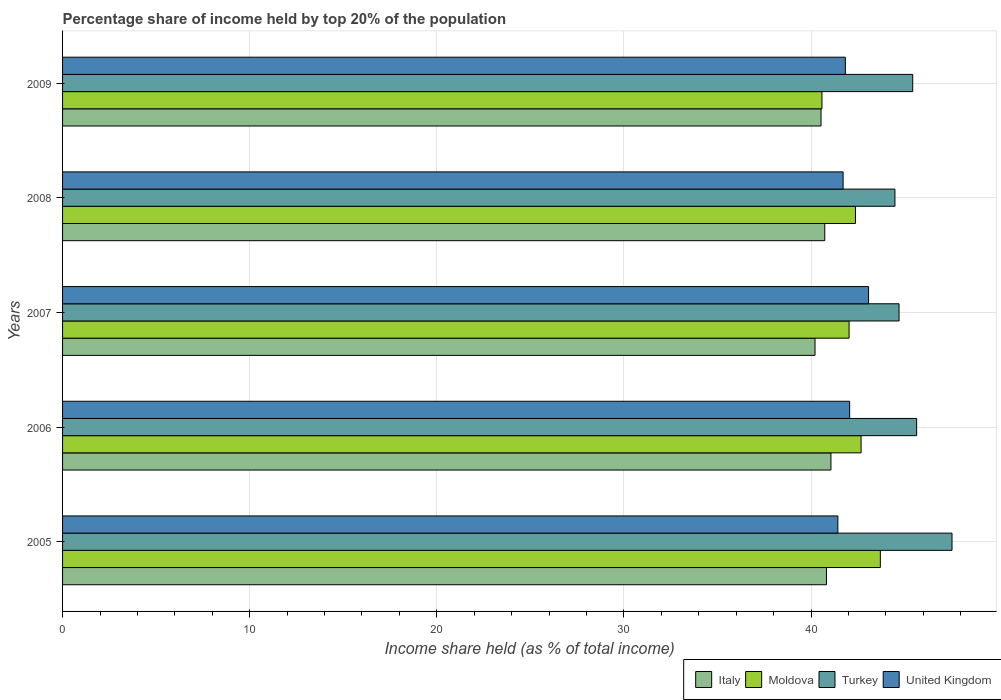How many different coloured bars are there?
Keep it short and to the point. 4. Are the number of bars per tick equal to the number of legend labels?
Your answer should be very brief. Yes. How many bars are there on the 1st tick from the top?
Ensure brevity in your answer.  4. What is the percentage share of income held by top 20% of the population in Turkey in 2005?
Offer a terse response. 47.53. Across all years, what is the maximum percentage share of income held by top 20% of the population in United Kingdom?
Offer a terse response. 43.07. Across all years, what is the minimum percentage share of income held by top 20% of the population in United Kingdom?
Offer a terse response. 41.43. In which year was the percentage share of income held by top 20% of the population in United Kingdom maximum?
Keep it short and to the point. 2007. What is the total percentage share of income held by top 20% of the population in Turkey in the graph?
Make the answer very short. 227.78. What is the difference between the percentage share of income held by top 20% of the population in Moldova in 2007 and that in 2008?
Ensure brevity in your answer.  -0.34. What is the difference between the percentage share of income held by top 20% of the population in United Kingdom in 2006 and the percentage share of income held by top 20% of the population in Turkey in 2009?
Offer a very short reply. -3.37. What is the average percentage share of income held by top 20% of the population in Turkey per year?
Keep it short and to the point. 45.56. In the year 2006, what is the difference between the percentage share of income held by top 20% of the population in Italy and percentage share of income held by top 20% of the population in Turkey?
Ensure brevity in your answer.  -4.58. In how many years, is the percentage share of income held by top 20% of the population in Turkey greater than 44 %?
Offer a terse response. 5. What is the ratio of the percentage share of income held by top 20% of the population in Moldova in 2007 to that in 2008?
Keep it short and to the point. 0.99. Is the percentage share of income held by top 20% of the population in Turkey in 2007 less than that in 2009?
Provide a succinct answer. Yes. What is the difference between the highest and the second highest percentage share of income held by top 20% of the population in Moldova?
Your answer should be very brief. 1.03. What is the difference between the highest and the lowest percentage share of income held by top 20% of the population in United Kingdom?
Your answer should be very brief. 1.64. Is the sum of the percentage share of income held by top 20% of the population in Italy in 2005 and 2008 greater than the maximum percentage share of income held by top 20% of the population in United Kingdom across all years?
Offer a very short reply. Yes. Is it the case that in every year, the sum of the percentage share of income held by top 20% of the population in Moldova and percentage share of income held by top 20% of the population in Turkey is greater than the sum of percentage share of income held by top 20% of the population in United Kingdom and percentage share of income held by top 20% of the population in Italy?
Keep it short and to the point. No. How many bars are there?
Provide a succinct answer. 20. How many years are there in the graph?
Provide a succinct answer. 5. Are the values on the major ticks of X-axis written in scientific E-notation?
Provide a succinct answer. No. Does the graph contain grids?
Offer a terse response. Yes. Where does the legend appear in the graph?
Your answer should be very brief. Bottom right. How many legend labels are there?
Ensure brevity in your answer.  4. What is the title of the graph?
Keep it short and to the point. Percentage share of income held by top 20% of the population. What is the label or title of the X-axis?
Your answer should be very brief. Income share held (as % of total income). What is the Income share held (as % of total income) in Italy in 2005?
Offer a terse response. 40.82. What is the Income share held (as % of total income) in Moldova in 2005?
Give a very brief answer. 43.7. What is the Income share held (as % of total income) in Turkey in 2005?
Offer a very short reply. 47.53. What is the Income share held (as % of total income) in United Kingdom in 2005?
Give a very brief answer. 41.43. What is the Income share held (as % of total income) in Italy in 2006?
Offer a terse response. 41.06. What is the Income share held (as % of total income) of Moldova in 2006?
Your answer should be compact. 42.67. What is the Income share held (as % of total income) in Turkey in 2006?
Your answer should be compact. 45.64. What is the Income share held (as % of total income) of United Kingdom in 2006?
Your answer should be very brief. 42.06. What is the Income share held (as % of total income) of Italy in 2007?
Your answer should be compact. 40.21. What is the Income share held (as % of total income) of Moldova in 2007?
Keep it short and to the point. 42.03. What is the Income share held (as % of total income) in Turkey in 2007?
Offer a terse response. 44.7. What is the Income share held (as % of total income) in United Kingdom in 2007?
Keep it short and to the point. 43.07. What is the Income share held (as % of total income) of Italy in 2008?
Provide a short and direct response. 40.73. What is the Income share held (as % of total income) of Moldova in 2008?
Offer a terse response. 42.37. What is the Income share held (as % of total income) of Turkey in 2008?
Give a very brief answer. 44.48. What is the Income share held (as % of total income) of United Kingdom in 2008?
Provide a short and direct response. 41.71. What is the Income share held (as % of total income) in Italy in 2009?
Ensure brevity in your answer.  40.53. What is the Income share held (as % of total income) of Moldova in 2009?
Your answer should be very brief. 40.58. What is the Income share held (as % of total income) of Turkey in 2009?
Make the answer very short. 45.43. What is the Income share held (as % of total income) of United Kingdom in 2009?
Provide a short and direct response. 41.83. Across all years, what is the maximum Income share held (as % of total income) in Italy?
Provide a succinct answer. 41.06. Across all years, what is the maximum Income share held (as % of total income) of Moldova?
Keep it short and to the point. 43.7. Across all years, what is the maximum Income share held (as % of total income) of Turkey?
Your answer should be very brief. 47.53. Across all years, what is the maximum Income share held (as % of total income) in United Kingdom?
Offer a very short reply. 43.07. Across all years, what is the minimum Income share held (as % of total income) in Italy?
Your response must be concise. 40.21. Across all years, what is the minimum Income share held (as % of total income) of Moldova?
Offer a very short reply. 40.58. Across all years, what is the minimum Income share held (as % of total income) of Turkey?
Provide a succinct answer. 44.48. Across all years, what is the minimum Income share held (as % of total income) in United Kingdom?
Your answer should be compact. 41.43. What is the total Income share held (as % of total income) in Italy in the graph?
Provide a succinct answer. 203.35. What is the total Income share held (as % of total income) in Moldova in the graph?
Your answer should be compact. 211.35. What is the total Income share held (as % of total income) in Turkey in the graph?
Keep it short and to the point. 227.78. What is the total Income share held (as % of total income) in United Kingdom in the graph?
Make the answer very short. 210.1. What is the difference between the Income share held (as % of total income) in Italy in 2005 and that in 2006?
Make the answer very short. -0.24. What is the difference between the Income share held (as % of total income) of Moldova in 2005 and that in 2006?
Make the answer very short. 1.03. What is the difference between the Income share held (as % of total income) of Turkey in 2005 and that in 2006?
Make the answer very short. 1.89. What is the difference between the Income share held (as % of total income) in United Kingdom in 2005 and that in 2006?
Ensure brevity in your answer.  -0.63. What is the difference between the Income share held (as % of total income) of Italy in 2005 and that in 2007?
Ensure brevity in your answer.  0.61. What is the difference between the Income share held (as % of total income) of Moldova in 2005 and that in 2007?
Keep it short and to the point. 1.67. What is the difference between the Income share held (as % of total income) in Turkey in 2005 and that in 2007?
Your response must be concise. 2.83. What is the difference between the Income share held (as % of total income) of United Kingdom in 2005 and that in 2007?
Offer a terse response. -1.64. What is the difference between the Income share held (as % of total income) of Italy in 2005 and that in 2008?
Offer a terse response. 0.09. What is the difference between the Income share held (as % of total income) of Moldova in 2005 and that in 2008?
Provide a short and direct response. 1.33. What is the difference between the Income share held (as % of total income) in Turkey in 2005 and that in 2008?
Provide a succinct answer. 3.05. What is the difference between the Income share held (as % of total income) in United Kingdom in 2005 and that in 2008?
Ensure brevity in your answer.  -0.28. What is the difference between the Income share held (as % of total income) of Italy in 2005 and that in 2009?
Your response must be concise. 0.29. What is the difference between the Income share held (as % of total income) of Moldova in 2005 and that in 2009?
Provide a short and direct response. 3.12. What is the difference between the Income share held (as % of total income) of Moldova in 2006 and that in 2007?
Ensure brevity in your answer.  0.64. What is the difference between the Income share held (as % of total income) in United Kingdom in 2006 and that in 2007?
Your answer should be very brief. -1.01. What is the difference between the Income share held (as % of total income) in Italy in 2006 and that in 2008?
Give a very brief answer. 0.33. What is the difference between the Income share held (as % of total income) in Moldova in 2006 and that in 2008?
Offer a terse response. 0.3. What is the difference between the Income share held (as % of total income) in Turkey in 2006 and that in 2008?
Keep it short and to the point. 1.16. What is the difference between the Income share held (as % of total income) of United Kingdom in 2006 and that in 2008?
Provide a succinct answer. 0.35. What is the difference between the Income share held (as % of total income) of Italy in 2006 and that in 2009?
Give a very brief answer. 0.53. What is the difference between the Income share held (as % of total income) in Moldova in 2006 and that in 2009?
Make the answer very short. 2.09. What is the difference between the Income share held (as % of total income) of Turkey in 2006 and that in 2009?
Your answer should be very brief. 0.21. What is the difference between the Income share held (as % of total income) in United Kingdom in 2006 and that in 2009?
Your answer should be very brief. 0.23. What is the difference between the Income share held (as % of total income) in Italy in 2007 and that in 2008?
Provide a short and direct response. -0.52. What is the difference between the Income share held (as % of total income) in Moldova in 2007 and that in 2008?
Your answer should be compact. -0.34. What is the difference between the Income share held (as % of total income) of Turkey in 2007 and that in 2008?
Offer a very short reply. 0.22. What is the difference between the Income share held (as % of total income) of United Kingdom in 2007 and that in 2008?
Offer a very short reply. 1.36. What is the difference between the Income share held (as % of total income) of Italy in 2007 and that in 2009?
Keep it short and to the point. -0.32. What is the difference between the Income share held (as % of total income) of Moldova in 2007 and that in 2009?
Give a very brief answer. 1.45. What is the difference between the Income share held (as % of total income) of Turkey in 2007 and that in 2009?
Your answer should be very brief. -0.73. What is the difference between the Income share held (as % of total income) of United Kingdom in 2007 and that in 2009?
Provide a succinct answer. 1.24. What is the difference between the Income share held (as % of total income) in Italy in 2008 and that in 2009?
Ensure brevity in your answer.  0.2. What is the difference between the Income share held (as % of total income) of Moldova in 2008 and that in 2009?
Offer a terse response. 1.79. What is the difference between the Income share held (as % of total income) in Turkey in 2008 and that in 2009?
Provide a short and direct response. -0.95. What is the difference between the Income share held (as % of total income) in United Kingdom in 2008 and that in 2009?
Your answer should be compact. -0.12. What is the difference between the Income share held (as % of total income) in Italy in 2005 and the Income share held (as % of total income) in Moldova in 2006?
Provide a short and direct response. -1.85. What is the difference between the Income share held (as % of total income) of Italy in 2005 and the Income share held (as % of total income) of Turkey in 2006?
Keep it short and to the point. -4.82. What is the difference between the Income share held (as % of total income) in Italy in 2005 and the Income share held (as % of total income) in United Kingdom in 2006?
Offer a terse response. -1.24. What is the difference between the Income share held (as % of total income) of Moldova in 2005 and the Income share held (as % of total income) of Turkey in 2006?
Provide a short and direct response. -1.94. What is the difference between the Income share held (as % of total income) in Moldova in 2005 and the Income share held (as % of total income) in United Kingdom in 2006?
Your answer should be very brief. 1.64. What is the difference between the Income share held (as % of total income) of Turkey in 2005 and the Income share held (as % of total income) of United Kingdom in 2006?
Your answer should be compact. 5.47. What is the difference between the Income share held (as % of total income) of Italy in 2005 and the Income share held (as % of total income) of Moldova in 2007?
Offer a very short reply. -1.21. What is the difference between the Income share held (as % of total income) in Italy in 2005 and the Income share held (as % of total income) in Turkey in 2007?
Ensure brevity in your answer.  -3.88. What is the difference between the Income share held (as % of total income) of Italy in 2005 and the Income share held (as % of total income) of United Kingdom in 2007?
Offer a very short reply. -2.25. What is the difference between the Income share held (as % of total income) in Moldova in 2005 and the Income share held (as % of total income) in United Kingdom in 2007?
Give a very brief answer. 0.63. What is the difference between the Income share held (as % of total income) in Turkey in 2005 and the Income share held (as % of total income) in United Kingdom in 2007?
Provide a short and direct response. 4.46. What is the difference between the Income share held (as % of total income) in Italy in 2005 and the Income share held (as % of total income) in Moldova in 2008?
Keep it short and to the point. -1.55. What is the difference between the Income share held (as % of total income) in Italy in 2005 and the Income share held (as % of total income) in Turkey in 2008?
Provide a succinct answer. -3.66. What is the difference between the Income share held (as % of total income) in Italy in 2005 and the Income share held (as % of total income) in United Kingdom in 2008?
Your answer should be very brief. -0.89. What is the difference between the Income share held (as % of total income) in Moldova in 2005 and the Income share held (as % of total income) in Turkey in 2008?
Ensure brevity in your answer.  -0.78. What is the difference between the Income share held (as % of total income) in Moldova in 2005 and the Income share held (as % of total income) in United Kingdom in 2008?
Offer a very short reply. 1.99. What is the difference between the Income share held (as % of total income) of Turkey in 2005 and the Income share held (as % of total income) of United Kingdom in 2008?
Your answer should be compact. 5.82. What is the difference between the Income share held (as % of total income) of Italy in 2005 and the Income share held (as % of total income) of Moldova in 2009?
Offer a terse response. 0.24. What is the difference between the Income share held (as % of total income) in Italy in 2005 and the Income share held (as % of total income) in Turkey in 2009?
Your answer should be very brief. -4.61. What is the difference between the Income share held (as % of total income) in Italy in 2005 and the Income share held (as % of total income) in United Kingdom in 2009?
Provide a short and direct response. -1.01. What is the difference between the Income share held (as % of total income) in Moldova in 2005 and the Income share held (as % of total income) in Turkey in 2009?
Provide a short and direct response. -1.73. What is the difference between the Income share held (as % of total income) in Moldova in 2005 and the Income share held (as % of total income) in United Kingdom in 2009?
Your response must be concise. 1.87. What is the difference between the Income share held (as % of total income) of Turkey in 2005 and the Income share held (as % of total income) of United Kingdom in 2009?
Your response must be concise. 5.7. What is the difference between the Income share held (as % of total income) in Italy in 2006 and the Income share held (as % of total income) in Moldova in 2007?
Your answer should be very brief. -0.97. What is the difference between the Income share held (as % of total income) in Italy in 2006 and the Income share held (as % of total income) in Turkey in 2007?
Provide a short and direct response. -3.64. What is the difference between the Income share held (as % of total income) in Italy in 2006 and the Income share held (as % of total income) in United Kingdom in 2007?
Provide a short and direct response. -2.01. What is the difference between the Income share held (as % of total income) of Moldova in 2006 and the Income share held (as % of total income) of Turkey in 2007?
Provide a short and direct response. -2.03. What is the difference between the Income share held (as % of total income) in Moldova in 2006 and the Income share held (as % of total income) in United Kingdom in 2007?
Your response must be concise. -0.4. What is the difference between the Income share held (as % of total income) of Turkey in 2006 and the Income share held (as % of total income) of United Kingdom in 2007?
Offer a very short reply. 2.57. What is the difference between the Income share held (as % of total income) of Italy in 2006 and the Income share held (as % of total income) of Moldova in 2008?
Offer a very short reply. -1.31. What is the difference between the Income share held (as % of total income) of Italy in 2006 and the Income share held (as % of total income) of Turkey in 2008?
Your answer should be very brief. -3.42. What is the difference between the Income share held (as % of total income) of Italy in 2006 and the Income share held (as % of total income) of United Kingdom in 2008?
Offer a terse response. -0.65. What is the difference between the Income share held (as % of total income) in Moldova in 2006 and the Income share held (as % of total income) in Turkey in 2008?
Keep it short and to the point. -1.81. What is the difference between the Income share held (as % of total income) in Moldova in 2006 and the Income share held (as % of total income) in United Kingdom in 2008?
Offer a very short reply. 0.96. What is the difference between the Income share held (as % of total income) of Turkey in 2006 and the Income share held (as % of total income) of United Kingdom in 2008?
Ensure brevity in your answer.  3.93. What is the difference between the Income share held (as % of total income) of Italy in 2006 and the Income share held (as % of total income) of Moldova in 2009?
Provide a succinct answer. 0.48. What is the difference between the Income share held (as % of total income) in Italy in 2006 and the Income share held (as % of total income) in Turkey in 2009?
Your response must be concise. -4.37. What is the difference between the Income share held (as % of total income) in Italy in 2006 and the Income share held (as % of total income) in United Kingdom in 2009?
Your answer should be compact. -0.77. What is the difference between the Income share held (as % of total income) of Moldova in 2006 and the Income share held (as % of total income) of Turkey in 2009?
Offer a very short reply. -2.76. What is the difference between the Income share held (as % of total income) of Moldova in 2006 and the Income share held (as % of total income) of United Kingdom in 2009?
Provide a succinct answer. 0.84. What is the difference between the Income share held (as % of total income) in Turkey in 2006 and the Income share held (as % of total income) in United Kingdom in 2009?
Provide a short and direct response. 3.81. What is the difference between the Income share held (as % of total income) in Italy in 2007 and the Income share held (as % of total income) in Moldova in 2008?
Ensure brevity in your answer.  -2.16. What is the difference between the Income share held (as % of total income) in Italy in 2007 and the Income share held (as % of total income) in Turkey in 2008?
Give a very brief answer. -4.27. What is the difference between the Income share held (as % of total income) of Moldova in 2007 and the Income share held (as % of total income) of Turkey in 2008?
Give a very brief answer. -2.45. What is the difference between the Income share held (as % of total income) of Moldova in 2007 and the Income share held (as % of total income) of United Kingdom in 2008?
Your response must be concise. 0.32. What is the difference between the Income share held (as % of total income) in Turkey in 2007 and the Income share held (as % of total income) in United Kingdom in 2008?
Provide a succinct answer. 2.99. What is the difference between the Income share held (as % of total income) of Italy in 2007 and the Income share held (as % of total income) of Moldova in 2009?
Your response must be concise. -0.37. What is the difference between the Income share held (as % of total income) of Italy in 2007 and the Income share held (as % of total income) of Turkey in 2009?
Your answer should be compact. -5.22. What is the difference between the Income share held (as % of total income) in Italy in 2007 and the Income share held (as % of total income) in United Kingdom in 2009?
Provide a short and direct response. -1.62. What is the difference between the Income share held (as % of total income) in Turkey in 2007 and the Income share held (as % of total income) in United Kingdom in 2009?
Offer a terse response. 2.87. What is the difference between the Income share held (as % of total income) in Italy in 2008 and the Income share held (as % of total income) in Turkey in 2009?
Offer a terse response. -4.7. What is the difference between the Income share held (as % of total income) of Moldova in 2008 and the Income share held (as % of total income) of Turkey in 2009?
Your response must be concise. -3.06. What is the difference between the Income share held (as % of total income) of Moldova in 2008 and the Income share held (as % of total income) of United Kingdom in 2009?
Provide a short and direct response. 0.54. What is the difference between the Income share held (as % of total income) of Turkey in 2008 and the Income share held (as % of total income) of United Kingdom in 2009?
Your answer should be compact. 2.65. What is the average Income share held (as % of total income) in Italy per year?
Provide a short and direct response. 40.67. What is the average Income share held (as % of total income) of Moldova per year?
Keep it short and to the point. 42.27. What is the average Income share held (as % of total income) of Turkey per year?
Provide a short and direct response. 45.56. What is the average Income share held (as % of total income) in United Kingdom per year?
Give a very brief answer. 42.02. In the year 2005, what is the difference between the Income share held (as % of total income) in Italy and Income share held (as % of total income) in Moldova?
Your answer should be compact. -2.88. In the year 2005, what is the difference between the Income share held (as % of total income) in Italy and Income share held (as % of total income) in Turkey?
Keep it short and to the point. -6.71. In the year 2005, what is the difference between the Income share held (as % of total income) in Italy and Income share held (as % of total income) in United Kingdom?
Offer a terse response. -0.61. In the year 2005, what is the difference between the Income share held (as % of total income) of Moldova and Income share held (as % of total income) of Turkey?
Keep it short and to the point. -3.83. In the year 2005, what is the difference between the Income share held (as % of total income) of Moldova and Income share held (as % of total income) of United Kingdom?
Provide a succinct answer. 2.27. In the year 2006, what is the difference between the Income share held (as % of total income) in Italy and Income share held (as % of total income) in Moldova?
Give a very brief answer. -1.61. In the year 2006, what is the difference between the Income share held (as % of total income) of Italy and Income share held (as % of total income) of Turkey?
Ensure brevity in your answer.  -4.58. In the year 2006, what is the difference between the Income share held (as % of total income) of Italy and Income share held (as % of total income) of United Kingdom?
Offer a very short reply. -1. In the year 2006, what is the difference between the Income share held (as % of total income) in Moldova and Income share held (as % of total income) in Turkey?
Offer a terse response. -2.97. In the year 2006, what is the difference between the Income share held (as % of total income) in Moldova and Income share held (as % of total income) in United Kingdom?
Provide a short and direct response. 0.61. In the year 2006, what is the difference between the Income share held (as % of total income) of Turkey and Income share held (as % of total income) of United Kingdom?
Keep it short and to the point. 3.58. In the year 2007, what is the difference between the Income share held (as % of total income) of Italy and Income share held (as % of total income) of Moldova?
Offer a terse response. -1.82. In the year 2007, what is the difference between the Income share held (as % of total income) in Italy and Income share held (as % of total income) in Turkey?
Your answer should be very brief. -4.49. In the year 2007, what is the difference between the Income share held (as % of total income) in Italy and Income share held (as % of total income) in United Kingdom?
Offer a very short reply. -2.86. In the year 2007, what is the difference between the Income share held (as % of total income) of Moldova and Income share held (as % of total income) of Turkey?
Ensure brevity in your answer.  -2.67. In the year 2007, what is the difference between the Income share held (as % of total income) of Moldova and Income share held (as % of total income) of United Kingdom?
Your response must be concise. -1.04. In the year 2007, what is the difference between the Income share held (as % of total income) in Turkey and Income share held (as % of total income) in United Kingdom?
Your answer should be compact. 1.63. In the year 2008, what is the difference between the Income share held (as % of total income) of Italy and Income share held (as % of total income) of Moldova?
Make the answer very short. -1.64. In the year 2008, what is the difference between the Income share held (as % of total income) in Italy and Income share held (as % of total income) in Turkey?
Offer a terse response. -3.75. In the year 2008, what is the difference between the Income share held (as % of total income) of Italy and Income share held (as % of total income) of United Kingdom?
Provide a short and direct response. -0.98. In the year 2008, what is the difference between the Income share held (as % of total income) of Moldova and Income share held (as % of total income) of Turkey?
Provide a succinct answer. -2.11. In the year 2008, what is the difference between the Income share held (as % of total income) of Moldova and Income share held (as % of total income) of United Kingdom?
Offer a very short reply. 0.66. In the year 2008, what is the difference between the Income share held (as % of total income) of Turkey and Income share held (as % of total income) of United Kingdom?
Offer a very short reply. 2.77. In the year 2009, what is the difference between the Income share held (as % of total income) in Italy and Income share held (as % of total income) in Moldova?
Provide a short and direct response. -0.05. In the year 2009, what is the difference between the Income share held (as % of total income) in Italy and Income share held (as % of total income) in United Kingdom?
Offer a terse response. -1.3. In the year 2009, what is the difference between the Income share held (as % of total income) in Moldova and Income share held (as % of total income) in Turkey?
Keep it short and to the point. -4.85. In the year 2009, what is the difference between the Income share held (as % of total income) of Moldova and Income share held (as % of total income) of United Kingdom?
Keep it short and to the point. -1.25. What is the ratio of the Income share held (as % of total income) of Moldova in 2005 to that in 2006?
Ensure brevity in your answer.  1.02. What is the ratio of the Income share held (as % of total income) of Turkey in 2005 to that in 2006?
Offer a terse response. 1.04. What is the ratio of the Income share held (as % of total income) of United Kingdom in 2005 to that in 2006?
Offer a very short reply. 0.98. What is the ratio of the Income share held (as % of total income) of Italy in 2005 to that in 2007?
Offer a very short reply. 1.02. What is the ratio of the Income share held (as % of total income) of Moldova in 2005 to that in 2007?
Your response must be concise. 1.04. What is the ratio of the Income share held (as % of total income) of Turkey in 2005 to that in 2007?
Your response must be concise. 1.06. What is the ratio of the Income share held (as % of total income) of United Kingdom in 2005 to that in 2007?
Offer a very short reply. 0.96. What is the ratio of the Income share held (as % of total income) in Moldova in 2005 to that in 2008?
Your answer should be very brief. 1.03. What is the ratio of the Income share held (as % of total income) of Turkey in 2005 to that in 2008?
Provide a short and direct response. 1.07. What is the ratio of the Income share held (as % of total income) of Moldova in 2005 to that in 2009?
Offer a very short reply. 1.08. What is the ratio of the Income share held (as % of total income) of Turkey in 2005 to that in 2009?
Keep it short and to the point. 1.05. What is the ratio of the Income share held (as % of total income) in United Kingdom in 2005 to that in 2009?
Provide a succinct answer. 0.99. What is the ratio of the Income share held (as % of total income) in Italy in 2006 to that in 2007?
Keep it short and to the point. 1.02. What is the ratio of the Income share held (as % of total income) in Moldova in 2006 to that in 2007?
Your response must be concise. 1.02. What is the ratio of the Income share held (as % of total income) in United Kingdom in 2006 to that in 2007?
Provide a succinct answer. 0.98. What is the ratio of the Income share held (as % of total income) in Moldova in 2006 to that in 2008?
Keep it short and to the point. 1.01. What is the ratio of the Income share held (as % of total income) of Turkey in 2006 to that in 2008?
Make the answer very short. 1.03. What is the ratio of the Income share held (as % of total income) in United Kingdom in 2006 to that in 2008?
Offer a very short reply. 1.01. What is the ratio of the Income share held (as % of total income) in Italy in 2006 to that in 2009?
Offer a very short reply. 1.01. What is the ratio of the Income share held (as % of total income) in Moldova in 2006 to that in 2009?
Your response must be concise. 1.05. What is the ratio of the Income share held (as % of total income) in Turkey in 2006 to that in 2009?
Provide a succinct answer. 1. What is the ratio of the Income share held (as % of total income) of United Kingdom in 2006 to that in 2009?
Provide a succinct answer. 1.01. What is the ratio of the Income share held (as % of total income) of Italy in 2007 to that in 2008?
Give a very brief answer. 0.99. What is the ratio of the Income share held (as % of total income) of Turkey in 2007 to that in 2008?
Keep it short and to the point. 1. What is the ratio of the Income share held (as % of total income) in United Kingdom in 2007 to that in 2008?
Your answer should be very brief. 1.03. What is the ratio of the Income share held (as % of total income) in Moldova in 2007 to that in 2009?
Keep it short and to the point. 1.04. What is the ratio of the Income share held (as % of total income) of Turkey in 2007 to that in 2009?
Ensure brevity in your answer.  0.98. What is the ratio of the Income share held (as % of total income) of United Kingdom in 2007 to that in 2009?
Keep it short and to the point. 1.03. What is the ratio of the Income share held (as % of total income) of Moldova in 2008 to that in 2009?
Make the answer very short. 1.04. What is the ratio of the Income share held (as % of total income) in Turkey in 2008 to that in 2009?
Ensure brevity in your answer.  0.98. What is the ratio of the Income share held (as % of total income) of United Kingdom in 2008 to that in 2009?
Your answer should be very brief. 1. What is the difference between the highest and the second highest Income share held (as % of total income) of Italy?
Your response must be concise. 0.24. What is the difference between the highest and the second highest Income share held (as % of total income) in Moldova?
Your answer should be compact. 1.03. What is the difference between the highest and the second highest Income share held (as % of total income) of Turkey?
Ensure brevity in your answer.  1.89. What is the difference between the highest and the second highest Income share held (as % of total income) in United Kingdom?
Offer a very short reply. 1.01. What is the difference between the highest and the lowest Income share held (as % of total income) in Italy?
Offer a very short reply. 0.85. What is the difference between the highest and the lowest Income share held (as % of total income) of Moldova?
Provide a short and direct response. 3.12. What is the difference between the highest and the lowest Income share held (as % of total income) in Turkey?
Provide a succinct answer. 3.05. What is the difference between the highest and the lowest Income share held (as % of total income) of United Kingdom?
Keep it short and to the point. 1.64. 